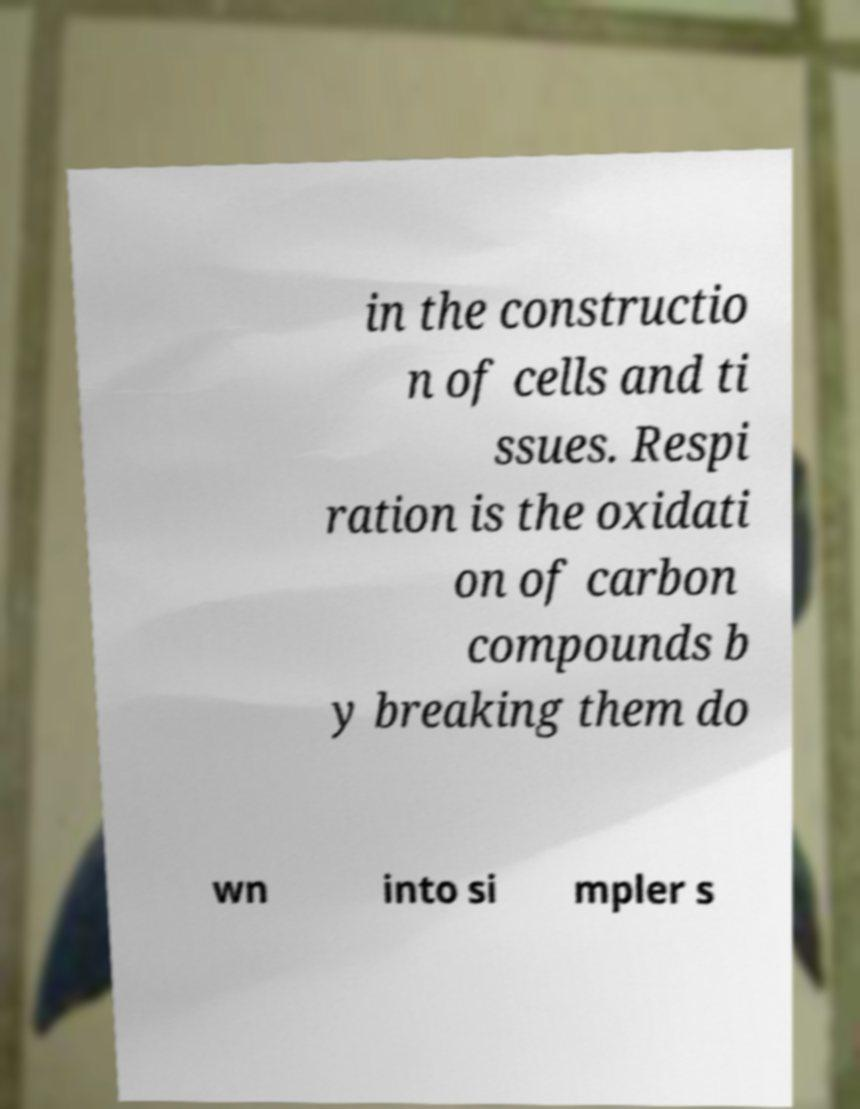Could you extract and type out the text from this image? in the constructio n of cells and ti ssues. Respi ration is the oxidati on of carbon compounds b y breaking them do wn into si mpler s 